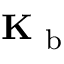<formula> <loc_0><loc_0><loc_500><loc_500>K _ { b }</formula> 